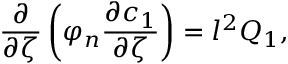<formula> <loc_0><loc_0><loc_500><loc_500>\frac { \partial } { \partial \zeta } \left ( \varphi _ { n } \frac { \partial c _ { 1 } } { \partial \zeta } \right ) = l ^ { 2 } Q _ { 1 } ,</formula> 